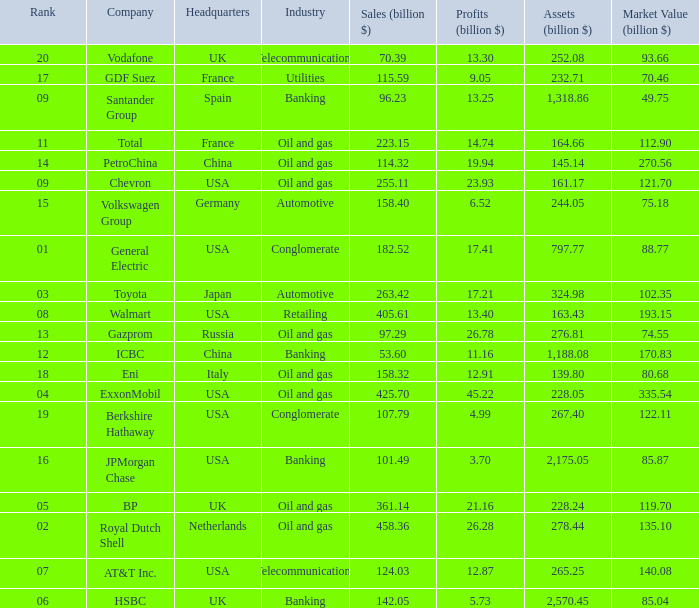Name the Sales (billion $) which have a Company of exxonmobil? 425.7. 